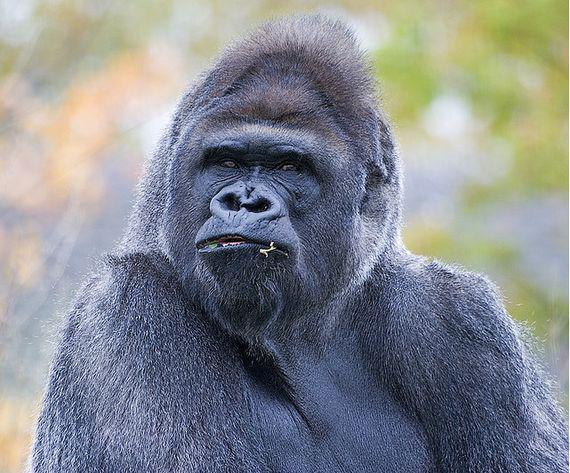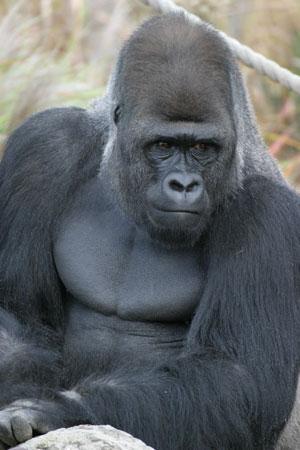The first image is the image on the left, the second image is the image on the right. Evaluate the accuracy of this statement regarding the images: "The animal in the image on the left is holding food.". Is it true? Answer yes or no. No. 